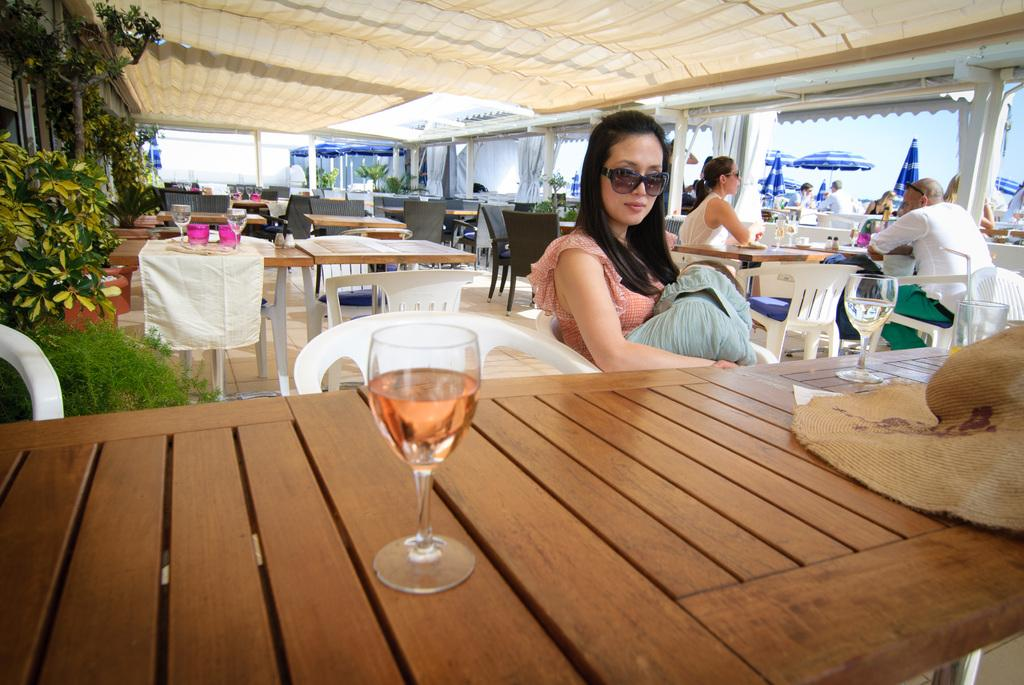What type of furniture is present in the image? There are many chairs and tables in the image. What are the people in the image doing? The people are sitting on the chairs. Can you describe any objects related to dining or socializing? There is a wine glass in the image. What type of vegetation can be seen in the image? There is a plant in the image. Are there any containers for plants visible? Yes, there is a flower pot in the image. Can you tell me how many kites are flying in the alley in the image? There is no alley or kites present in the image; it features chairs, tables, people, a wine glass, a plant, and a flower pot. 